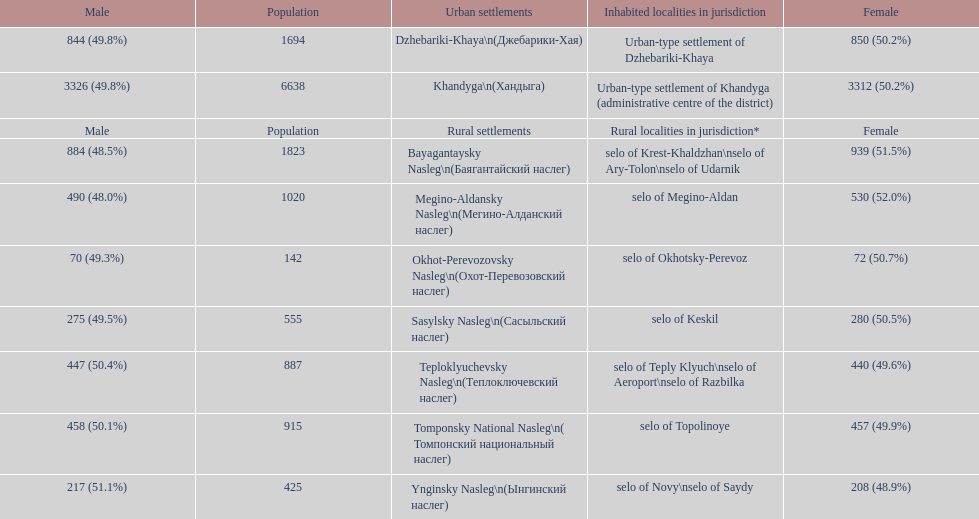Which rural settlement has the most males in their population? Bayagantaysky Nasleg (Áàÿãàíòàéñêèé íàñëåã). 